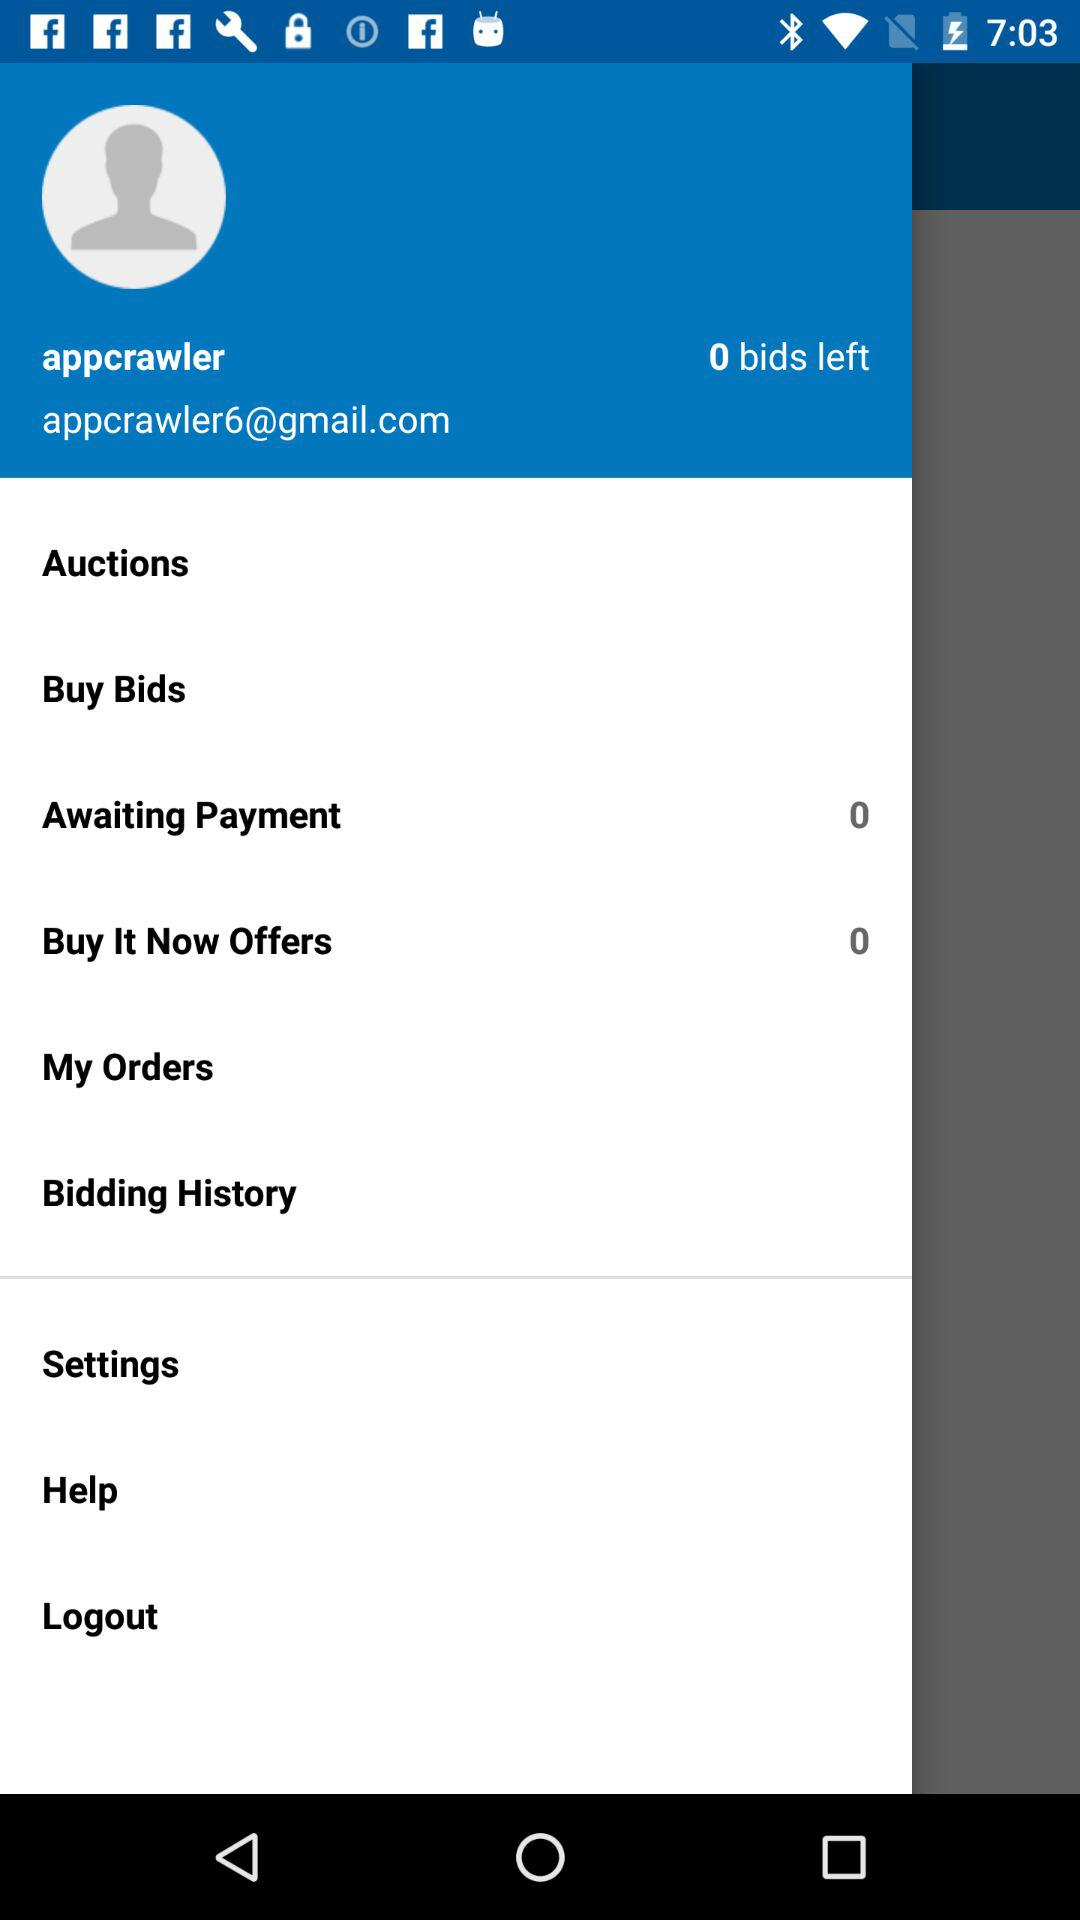How many "Buy It Now" offers are there? There are 0 offers. 